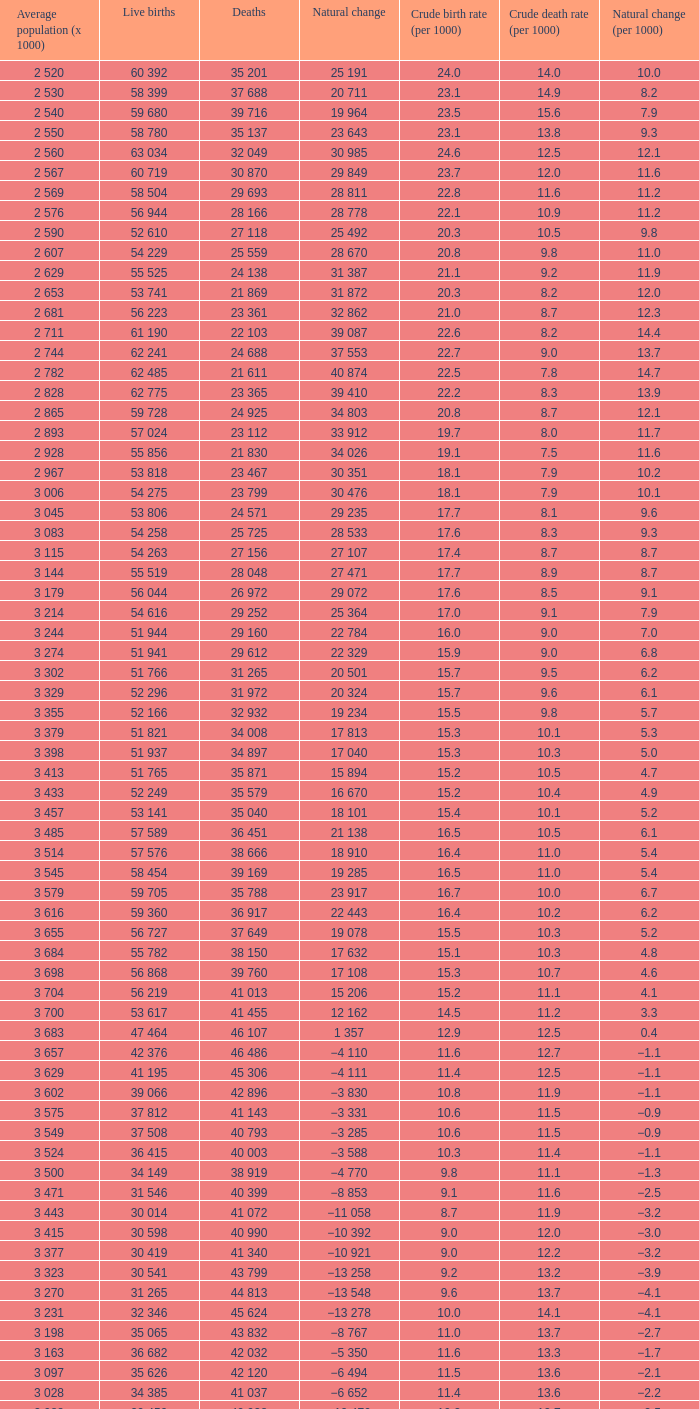7, and a natural change (per 1000) of 3 115. Write the full table. {'header': ['Average population (x 1000)', 'Live births', 'Deaths', 'Natural change', 'Crude birth rate (per 1000)', 'Crude death rate (per 1000)', 'Natural change (per 1000)'], 'rows': [['2 520', '60 392', '35 201', '25 191', '24.0', '14.0', '10.0'], ['2 530', '58 399', '37 688', '20 711', '23.1', '14.9', '8.2'], ['2 540', '59 680', '39 716', '19 964', '23.5', '15.6', '7.9'], ['2 550', '58 780', '35 137', '23 643', '23.1', '13.8', '9.3'], ['2 560', '63 034', '32 049', '30 985', '24.6', '12.5', '12.1'], ['2 567', '60 719', '30 870', '29 849', '23.7', '12.0', '11.6'], ['2 569', '58 504', '29 693', '28 811', '22.8', '11.6', '11.2'], ['2 576', '56 944', '28 166', '28 778', '22.1', '10.9', '11.2'], ['2 590', '52 610', '27 118', '25 492', '20.3', '10.5', '9.8'], ['2 607', '54 229', '25 559', '28 670', '20.8', '9.8', '11.0'], ['2 629', '55 525', '24 138', '31 387', '21.1', '9.2', '11.9'], ['2 653', '53 741', '21 869', '31 872', '20.3', '8.2', '12.0'], ['2 681', '56 223', '23 361', '32 862', '21.0', '8.7', '12.3'], ['2 711', '61 190', '22 103', '39 087', '22.6', '8.2', '14.4'], ['2 744', '62 241', '24 688', '37 553', '22.7', '9.0', '13.7'], ['2 782', '62 485', '21 611', '40 874', '22.5', '7.8', '14.7'], ['2 828', '62 775', '23 365', '39 410', '22.2', '8.3', '13.9'], ['2 865', '59 728', '24 925', '34 803', '20.8', '8.7', '12.1'], ['2 893', '57 024', '23 112', '33 912', '19.7', '8.0', '11.7'], ['2 928', '55 856', '21 830', '34 026', '19.1', '7.5', '11.6'], ['2 967', '53 818', '23 467', '30 351', '18.1', '7.9', '10.2'], ['3 006', '54 275', '23 799', '30 476', '18.1', '7.9', '10.1'], ['3 045', '53 806', '24 571', '29 235', '17.7', '8.1', '9.6'], ['3 083', '54 258', '25 725', '28 533', '17.6', '8.3', '9.3'], ['3 115', '54 263', '27 156', '27 107', '17.4', '8.7', '8.7'], ['3 144', '55 519', '28 048', '27 471', '17.7', '8.9', '8.7'], ['3 179', '56 044', '26 972', '29 072', '17.6', '8.5', '9.1'], ['3 214', '54 616', '29 252', '25 364', '17.0', '9.1', '7.9'], ['3 244', '51 944', '29 160', '22 784', '16.0', '9.0', '7.0'], ['3 274', '51 941', '29 612', '22 329', '15.9', '9.0', '6.8'], ['3 302', '51 766', '31 265', '20 501', '15.7', '9.5', '6.2'], ['3 329', '52 296', '31 972', '20 324', '15.7', '9.6', '6.1'], ['3 355', '52 166', '32 932', '19 234', '15.5', '9.8', '5.7'], ['3 379', '51 821', '34 008', '17 813', '15.3', '10.1', '5.3'], ['3 398', '51 937', '34 897', '17 040', '15.3', '10.3', '5.0'], ['3 413', '51 765', '35 871', '15 894', '15.2', '10.5', '4.7'], ['3 433', '52 249', '35 579', '16 670', '15.2', '10.4', '4.9'], ['3 457', '53 141', '35 040', '18 101', '15.4', '10.1', '5.2'], ['3 485', '57 589', '36 451', '21 138', '16.5', '10.5', '6.1'], ['3 514', '57 576', '38 666', '18 910', '16.4', '11.0', '5.4'], ['3 545', '58 454', '39 169', '19 285', '16.5', '11.0', '5.4'], ['3 579', '59 705', '35 788', '23 917', '16.7', '10.0', '6.7'], ['3 616', '59 360', '36 917', '22 443', '16.4', '10.2', '6.2'], ['3 655', '56 727', '37 649', '19 078', '15.5', '10.3', '5.2'], ['3 684', '55 782', '38 150', '17 632', '15.1', '10.3', '4.8'], ['3 698', '56 868', '39 760', '17 108', '15.3', '10.7', '4.6'], ['3 704', '56 219', '41 013', '15 206', '15.2', '11.1', '4.1'], ['3 700', '53 617', '41 455', '12 162', '14.5', '11.2', '3.3'], ['3 683', '47 464', '46 107', '1 357', '12.9', '12.5', '0.4'], ['3 657', '42 376', '46 486', '−4 110', '11.6', '12.7', '−1.1'], ['3 629', '41 195', '45 306', '−4 111', '11.4', '12.5', '−1.1'], ['3 602', '39 066', '42 896', '−3 830', '10.8', '11.9', '−1.1'], ['3 575', '37 812', '41 143', '−3 331', '10.6', '11.5', '−0.9'], ['3 549', '37 508', '40 793', '−3 285', '10.6', '11.5', '−0.9'], ['3 524', '36 415', '40 003', '−3 588', '10.3', '11.4', '−1.1'], ['3 500', '34 149', '38 919', '−4 770', '9.8', '11.1', '−1.3'], ['3 471', '31 546', '40 399', '−8 853', '9.1', '11.6', '−2.5'], ['3 443', '30 014', '41 072', '−11 058', '8.7', '11.9', '−3.2'], ['3 415', '30 598', '40 990', '−10 392', '9.0', '12.0', '−3.0'], ['3 377', '30 419', '41 340', '−10 921', '9.0', '12.2', '−3.2'], ['3 323', '30 541', '43 799', '−13 258', '9.2', '13.2', '−3.9'], ['3 270', '31 265', '44 813', '−13 548', '9.6', '13.7', '−4.1'], ['3 231', '32 346', '45 624', '−13 278', '10.0', '14.1', '−4.1'], ['3 198', '35 065', '43 832', '−8 767', '11.0', '13.7', '−2.7'], ['3 163', '36 682', '42 032', '−5 350', '11.6', '13.3', '−1.7'], ['3 097', '35 626', '42 120', '−6 494', '11.5', '13.6', '−2.1'], ['3 028', '34 385', '41 037', '−6 652', '11.4', '13.6', '−2.2'], ['2 988', '30 459', '40 938', '−10 479', '10.2', '13.7', '−3.5']]} 